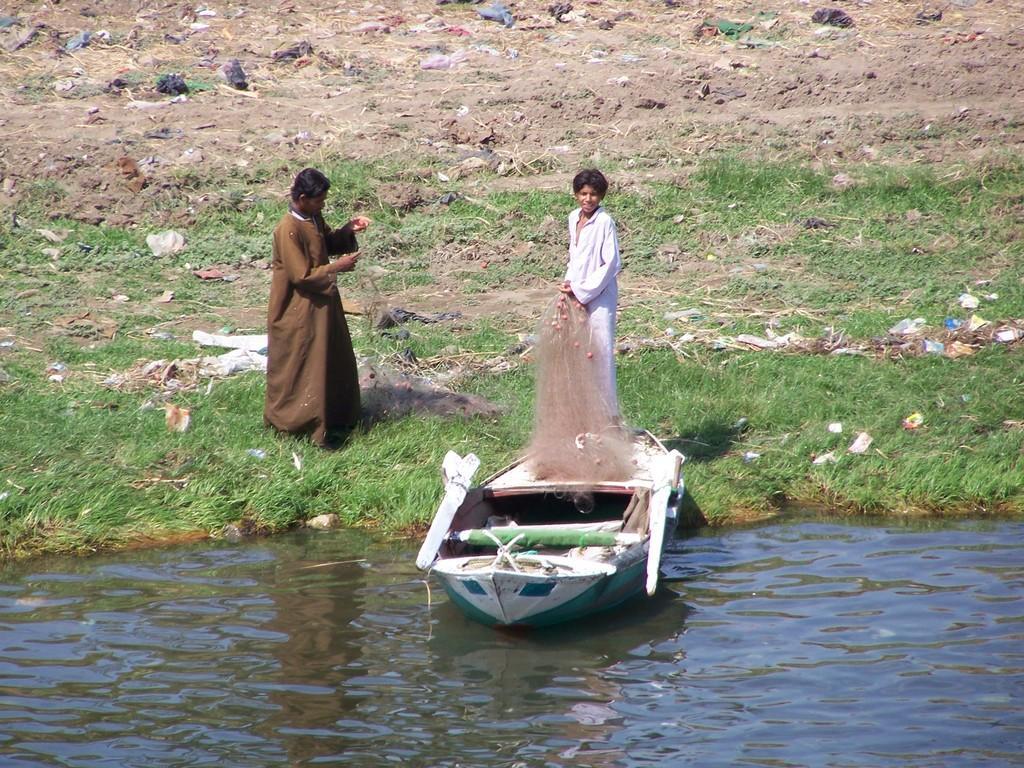How would you summarize this image in a sentence or two? In this picture I can see the boat on the water. I can see two people on the green grass. I can see fishing net. 